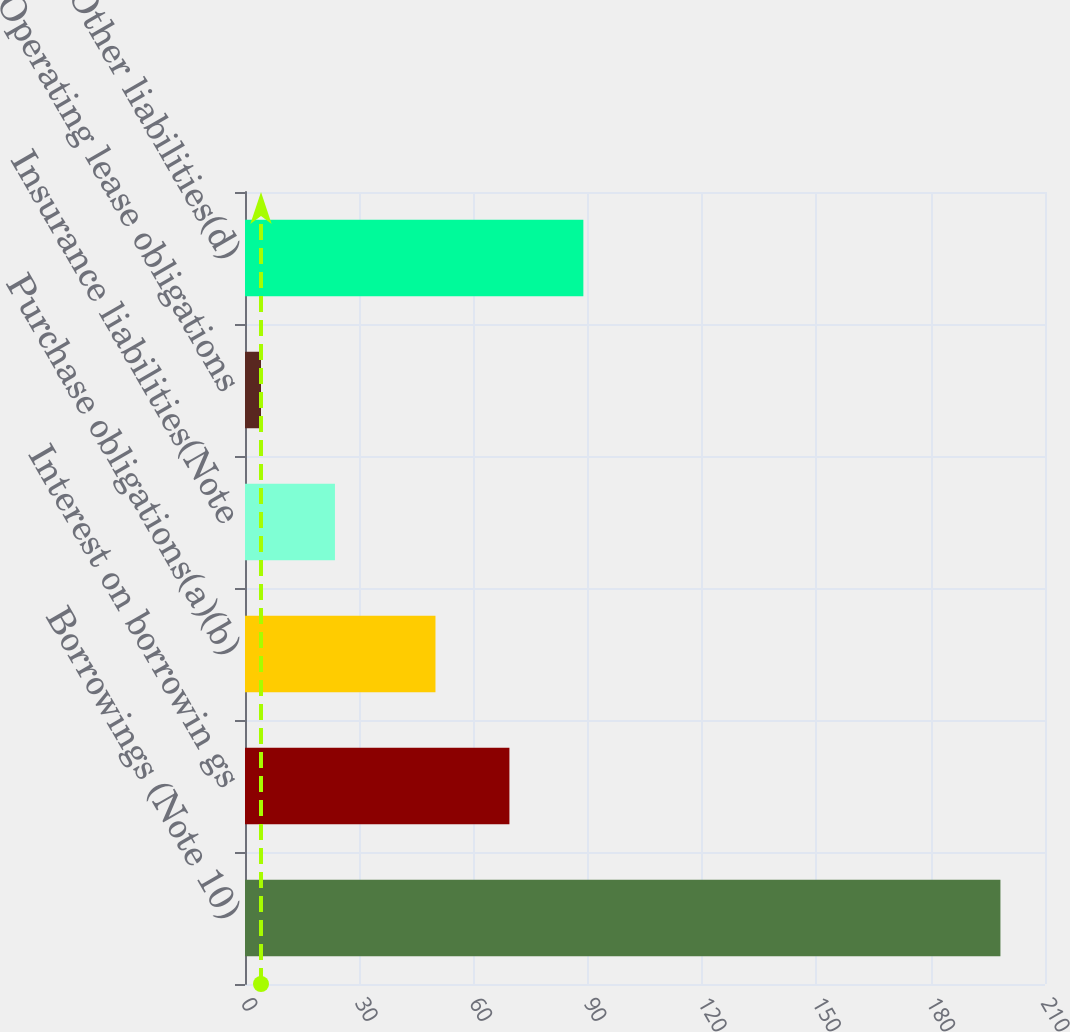Convert chart. <chart><loc_0><loc_0><loc_500><loc_500><bar_chart><fcel>Borrowings (Note 10)<fcel>Interest on borrowin gs<fcel>Purchase obligations(a)(b)<fcel>Insurance liabilities(Note<fcel>Operating lease obligations<fcel>Other liabilities(d)<nl><fcel>198.3<fcel>69.41<fcel>50<fcel>23.61<fcel>4.2<fcel>88.82<nl></chart> 